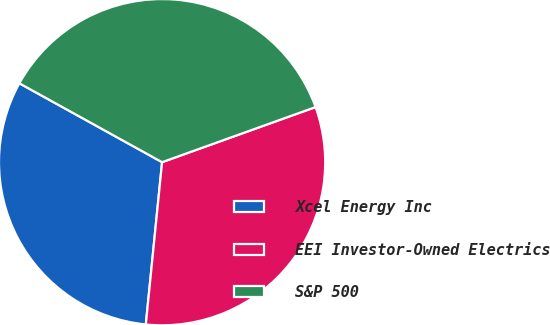<chart> <loc_0><loc_0><loc_500><loc_500><pie_chart><fcel>Xcel Energy Inc<fcel>EEI Investor-Owned Electrics<fcel>S&P 500<nl><fcel>31.45%<fcel>32.08%<fcel>36.48%<nl></chart> 